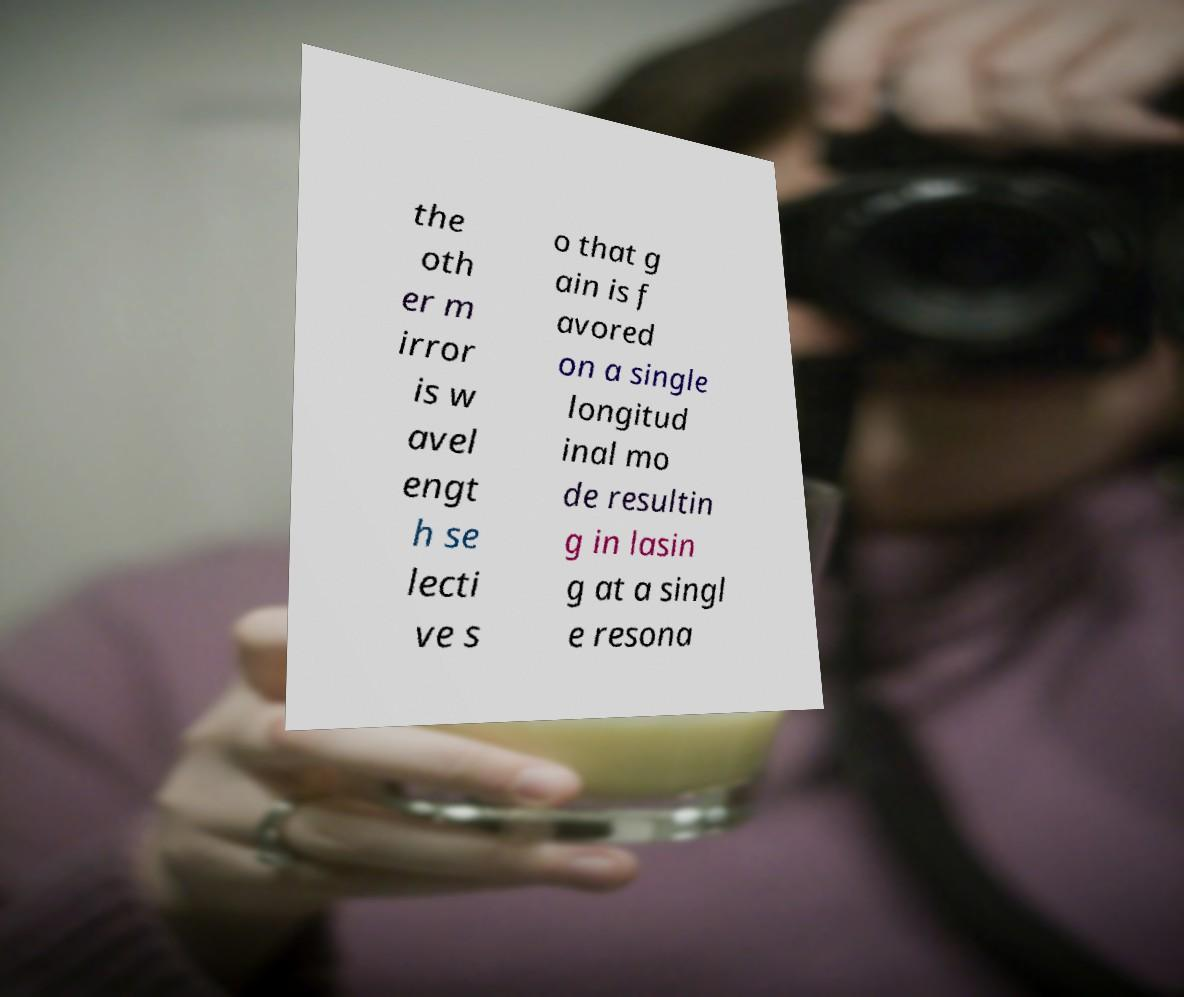Please identify and transcribe the text found in this image. the oth er m irror is w avel engt h se lecti ve s o that g ain is f avored on a single longitud inal mo de resultin g in lasin g at a singl e resona 